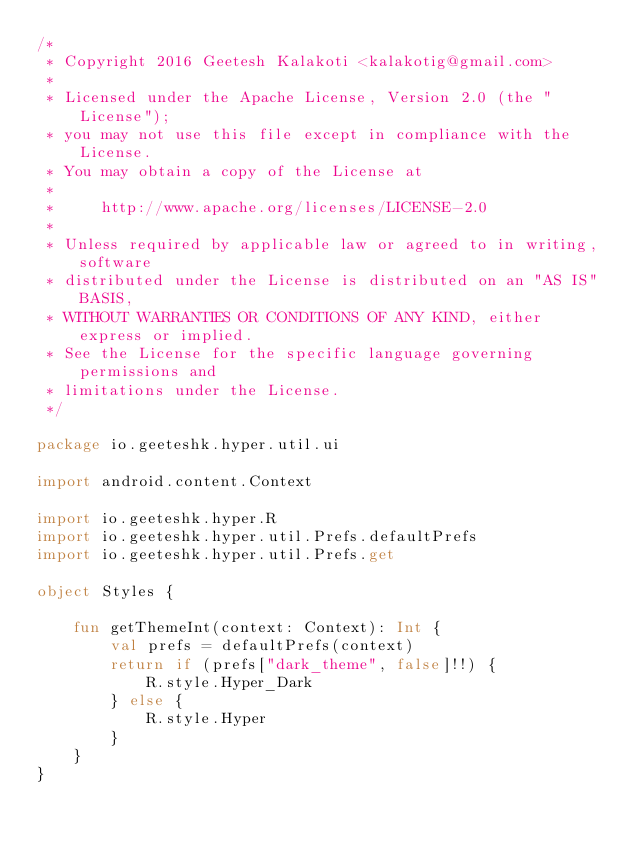<code> <loc_0><loc_0><loc_500><loc_500><_Kotlin_>/*
 * Copyright 2016 Geetesh Kalakoti <kalakotig@gmail.com>
 *
 * Licensed under the Apache License, Version 2.0 (the "License");
 * you may not use this file except in compliance with the License.
 * You may obtain a copy of the License at
 *
 *     http://www.apache.org/licenses/LICENSE-2.0
 *
 * Unless required by applicable law or agreed to in writing, software
 * distributed under the License is distributed on an "AS IS" BASIS,
 * WITHOUT WARRANTIES OR CONDITIONS OF ANY KIND, either express or implied.
 * See the License for the specific language governing permissions and
 * limitations under the License.
 */

package io.geeteshk.hyper.util.ui

import android.content.Context

import io.geeteshk.hyper.R
import io.geeteshk.hyper.util.Prefs.defaultPrefs
import io.geeteshk.hyper.util.Prefs.get

object Styles {

    fun getThemeInt(context: Context): Int {
        val prefs = defaultPrefs(context)
        return if (prefs["dark_theme", false]!!) {
            R.style.Hyper_Dark
        } else {
            R.style.Hyper
        }
    }
}
</code> 